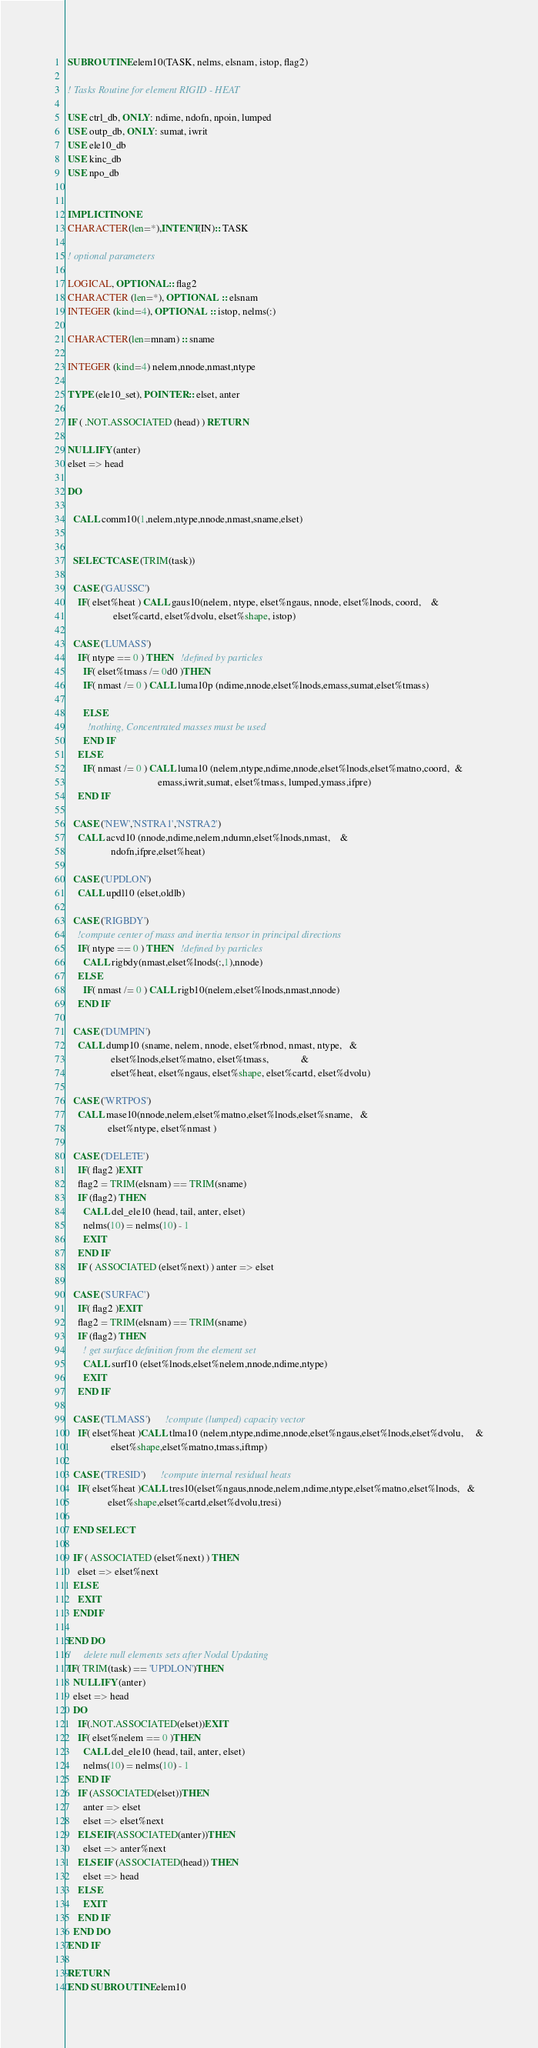Convert code to text. <code><loc_0><loc_0><loc_500><loc_500><_FORTRAN_> SUBROUTINE elem10(TASK, nelms, elsnam, istop, flag2)

 ! Tasks Routine for element RIGID - HEAT

 USE ctrl_db, ONLY: ndime, ndofn, npoin, lumped
 USE outp_db, ONLY: sumat, iwrit
 USE ele10_db
 USE kinc_db
 USE npo_db


 IMPLICIT NONE
 CHARACTER(len=*),INTENT(IN):: TASK

 ! optional parameters

 LOGICAL, OPTIONAL :: flag2
 CHARACTER (len=*), OPTIONAL  :: elsnam
 INTEGER (kind=4), OPTIONAL  :: istop, nelms(:)

 CHARACTER(len=mnam) :: sname

 INTEGER (kind=4) nelem,nnode,nmast,ntype

 TYPE (ele10_set), POINTER :: elset, anter

 IF ( .NOT.ASSOCIATED (head) ) RETURN

 NULLIFY (anter)
 elset => head

 DO

   CALL comm10(1,nelem,ntype,nnode,nmast,sname,elset)


   SELECT CASE (TRIM(task))

   CASE ('GAUSSC')
     IF( elset%heat ) CALL gaus10(nelem, ntype, elset%ngaus, nnode, elset%lnods, coord,    &
                   elset%cartd, elset%dvolu, elset%shape, istop)

   CASE ('LUMASS')
     IF( ntype == 0 ) THEN   !defined by particles
       IF( elset%tmass /= 0d0 )THEN
       IF( nmast /= 0 ) CALL luma10p (ndime,nnode,elset%lnods,emass,sumat,elset%tmass)

       ELSE
         !nothing, Concentrated masses must be used
       END IF
     ELSE
       IF( nmast /= 0 ) CALL luma10 (nelem,ntype,ndime,nnode,elset%lnods,elset%matno,coord,  &
                                     emass,iwrit,sumat, elset%tmass, lumped,ymass,ifpre)
     END IF

   CASE ('NEW','NSTRA1','NSTRA2')
     CALL acvd10 (nnode,ndime,nelem,ndumn,elset%lnods,nmast,    &
                  ndofn,ifpre,elset%heat)

   CASE ('UPDLON')
     CALL updl10 (elset,oldlb)

   CASE ('RIGBDY')
     !compute center of mass and inertia tensor in principal directions
     IF( ntype == 0 ) THEN   !defined by particles
       CALL rigbdy(nmast,elset%lnods(:,1),nnode)
     ELSE
       IF( nmast /= 0 ) CALL rigb10(nelem,elset%lnods,nmast,nnode)
     END IF

   CASE ('DUMPIN')
     CALL dump10 (sname, nelem, nnode, elset%rbnod, nmast, ntype,   &
                  elset%lnods,elset%matno, elset%tmass,             &
                  elset%heat, elset%ngaus, elset%shape, elset%cartd, elset%dvolu)

   CASE ('WRTPOS')
     CALL mase10(nnode,nelem,elset%matno,elset%lnods,elset%sname,   &
                 elset%ntype, elset%nmast )

   CASE ('DELETE')
     IF( flag2 )EXIT
     flag2 = TRIM(elsnam) == TRIM(sname)
     IF (flag2) THEN
       CALL del_ele10 (head, tail, anter, elset)
       nelms(10) = nelms(10) - 1
       EXIT
     END IF
     IF ( ASSOCIATED (elset%next) ) anter => elset

   CASE ('SURFAC')
     IF( flag2 )EXIT
     flag2 = TRIM(elsnam) == TRIM(sname)
     IF (flag2) THEN
       ! get surface definition from the element set
       CALL surf10 (elset%lnods,elset%nelem,nnode,ndime,ntype)
       EXIT
     END IF

   CASE ('TLMASS')      !compute (lumped) capacity vector
     IF( elset%heat )CALL tlma10 (nelem,ntype,ndime,nnode,elset%ngaus,elset%lnods,elset%dvolu,     &
                  elset%shape,elset%matno,tmass,iftmp)

   CASE ('TRESID')      !compute internal residual heats
     IF( elset%heat )CALL tres10(elset%ngaus,nnode,nelem,ndime,ntype,elset%matno,elset%lnods,   &
                 elset%shape,elset%cartd,elset%dvolu,tresi)

   END SELECT

   IF ( ASSOCIATED (elset%next) ) THEN
     elset => elset%next
   ELSE
     EXIT
   ENDIF

 END DO
 !     delete null elements sets after Nodal Updating
 IF( TRIM(task) == 'UPDLON')THEN
   NULLIFY (anter)
   elset => head
   DO
     IF(.NOT.ASSOCIATED(elset))EXIT    
     IF( elset%nelem == 0 )THEN
       CALL del_ele10 (head, tail, anter, elset)
       nelms(10) = nelms(10) - 1
     END IF
     IF (ASSOCIATED(elset))THEN
       anter => elset
       elset => elset%next
     ELSE IF(ASSOCIATED(anter))THEN
       elset => anter%next
     ELSE IF (ASSOCIATED(head)) THEN
       elset => head
     ELSE
       EXIT
     END IF
   END DO
 END IF

 RETURN
 END SUBROUTINE elem10
</code> 